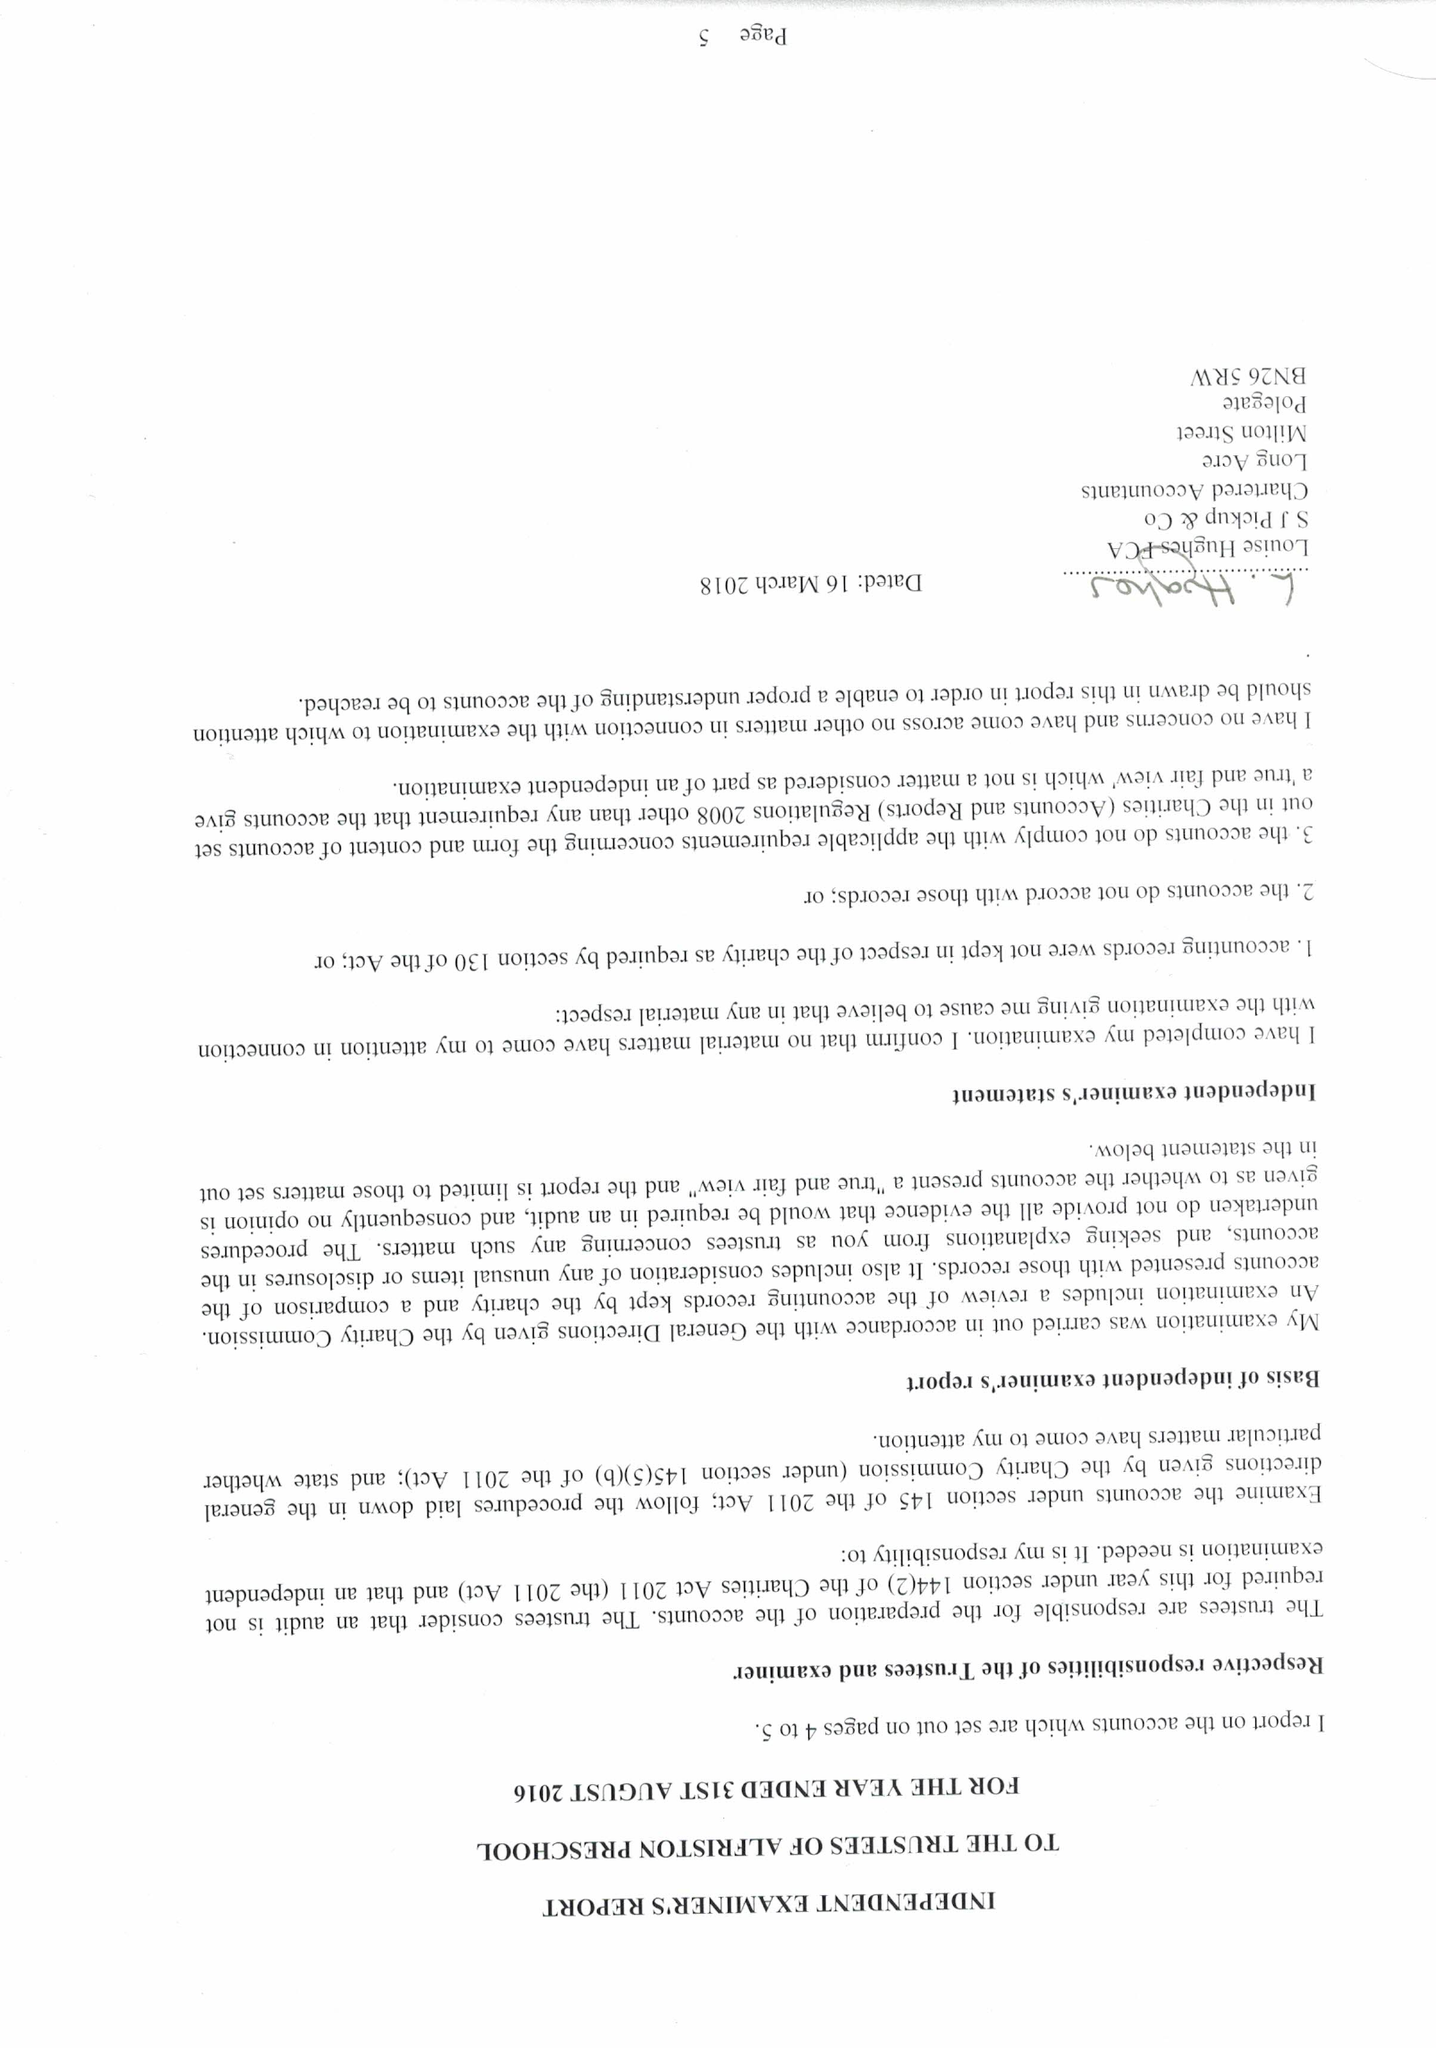What is the value for the address__street_line?
Answer the question using a single word or phrase. None 